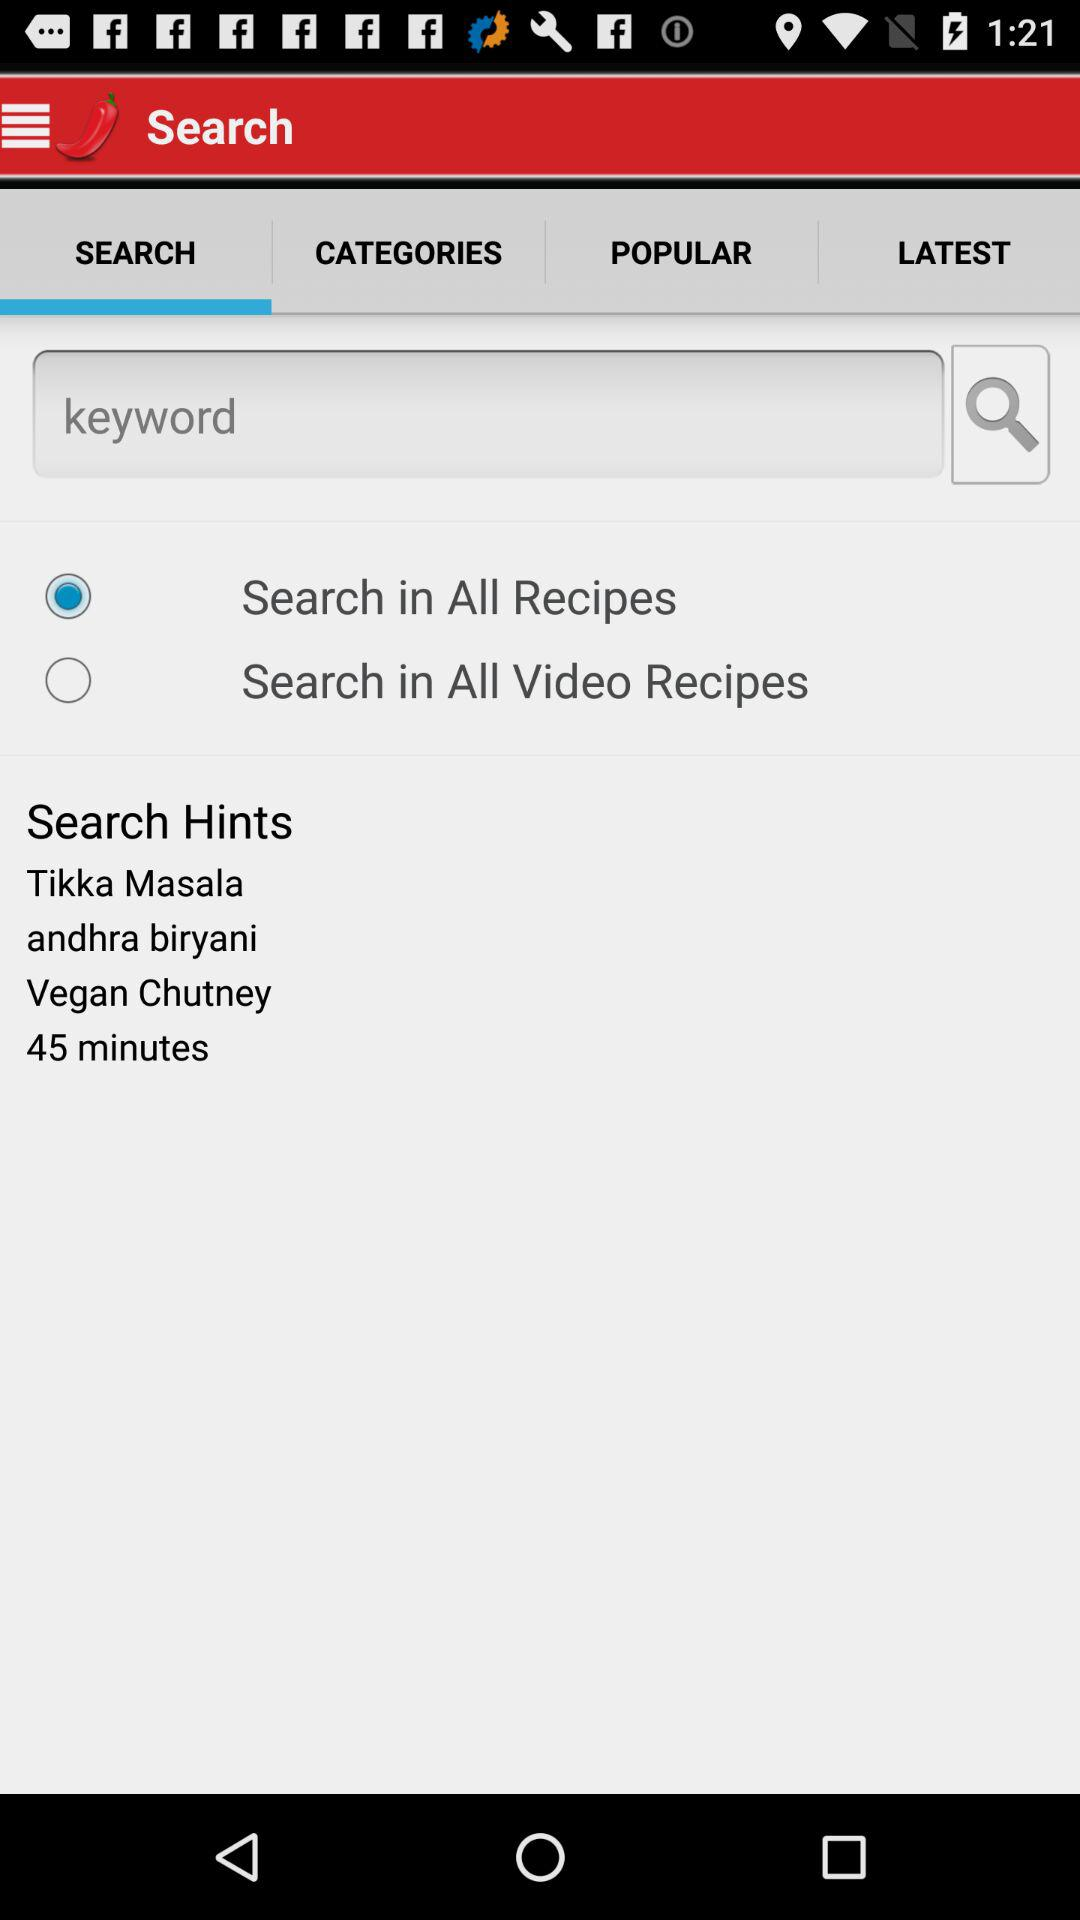Is "Search in All Recipes" selected or not? "Search in All Recipes" is selected. 